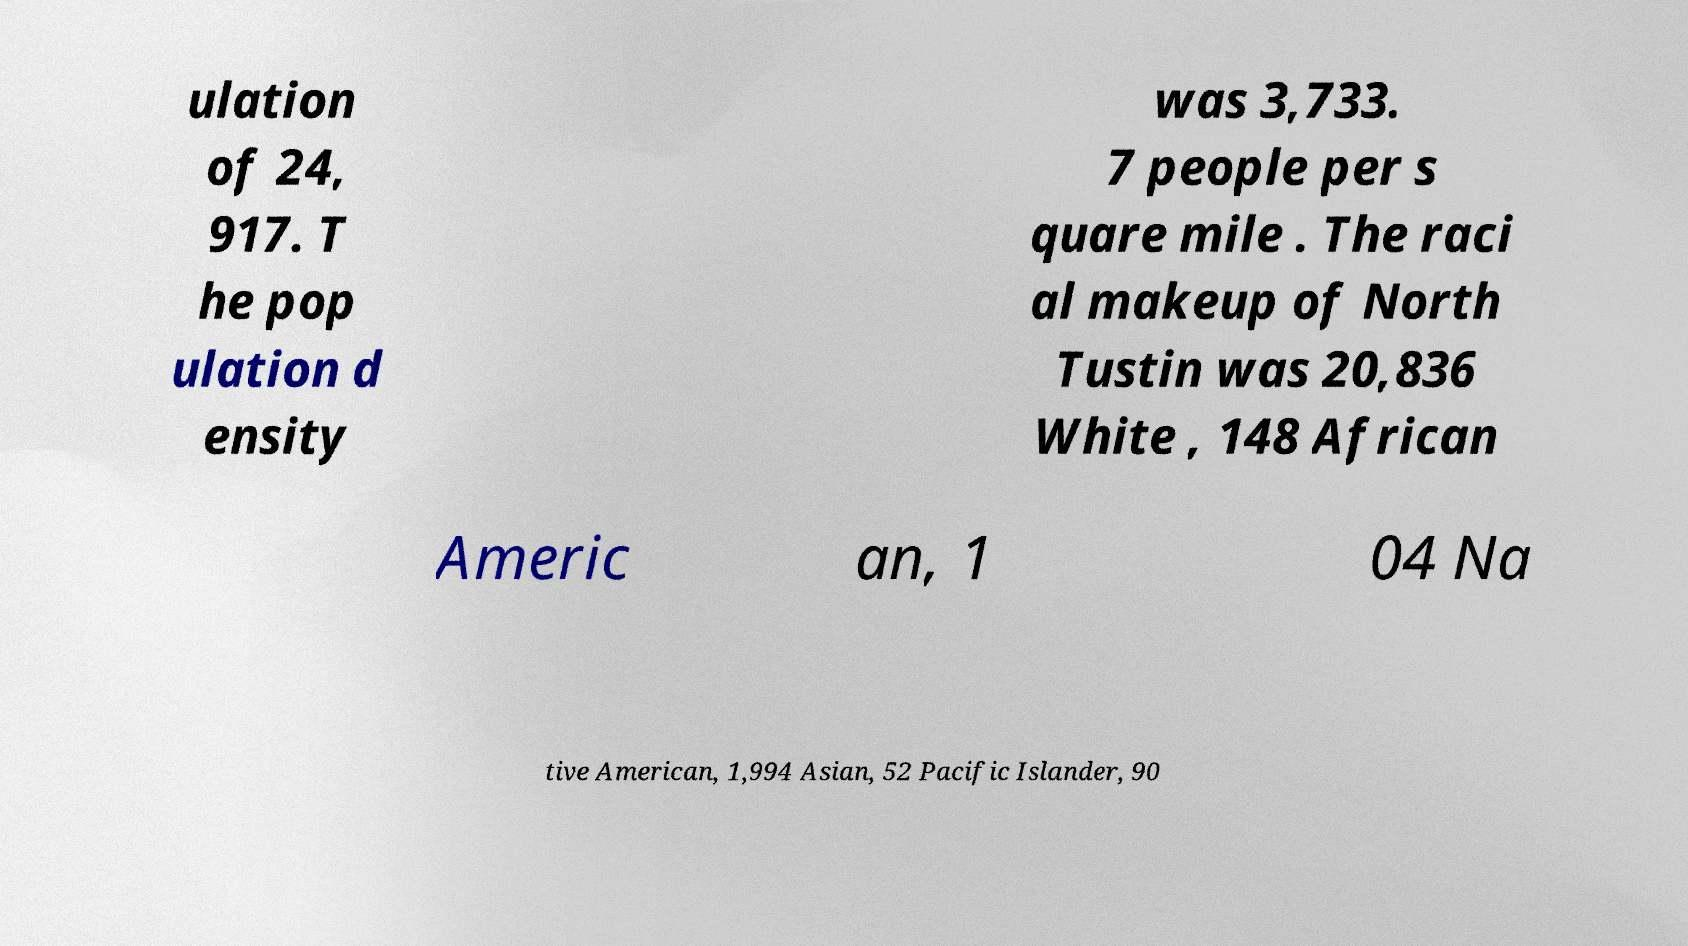For documentation purposes, I need the text within this image transcribed. Could you provide that? ulation of 24, 917. T he pop ulation d ensity was 3,733. 7 people per s quare mile . The raci al makeup of North Tustin was 20,836 White , 148 African Americ an, 1 04 Na tive American, 1,994 Asian, 52 Pacific Islander, 90 